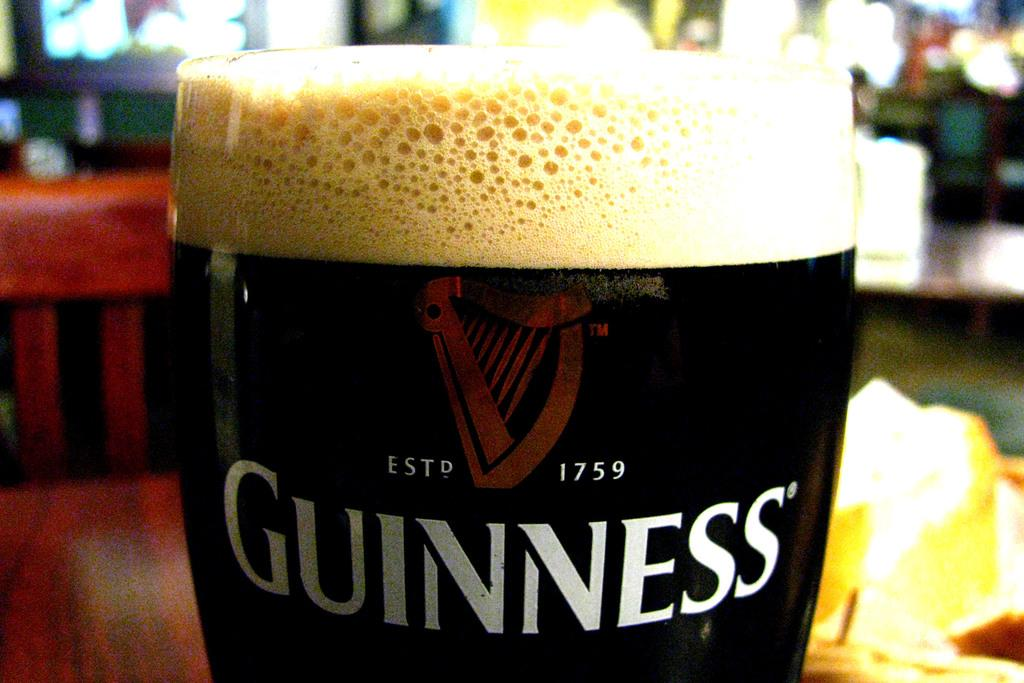<image>
Write a terse but informative summary of the picture. A glass on a table that has Guinness written on it. 